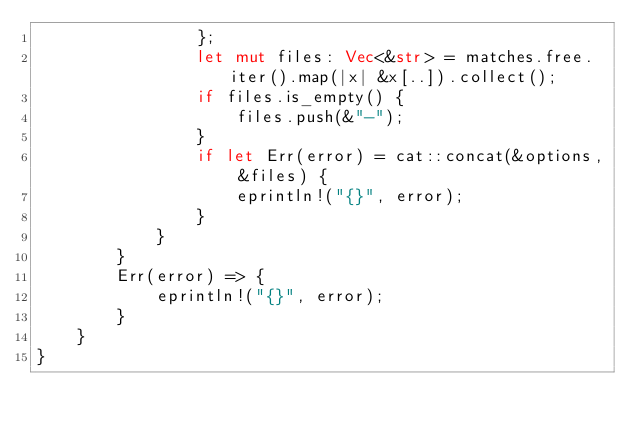Convert code to text. <code><loc_0><loc_0><loc_500><loc_500><_Rust_>                };
                let mut files: Vec<&str> = matches.free.iter().map(|x| &x[..]).collect();
                if files.is_empty() {
                    files.push(&"-");
                }
                if let Err(error) = cat::concat(&options, &files) {
                    eprintln!("{}", error);
                }
            }
        }
        Err(error) => {
            eprintln!("{}", error);
        }
    }
}
</code> 